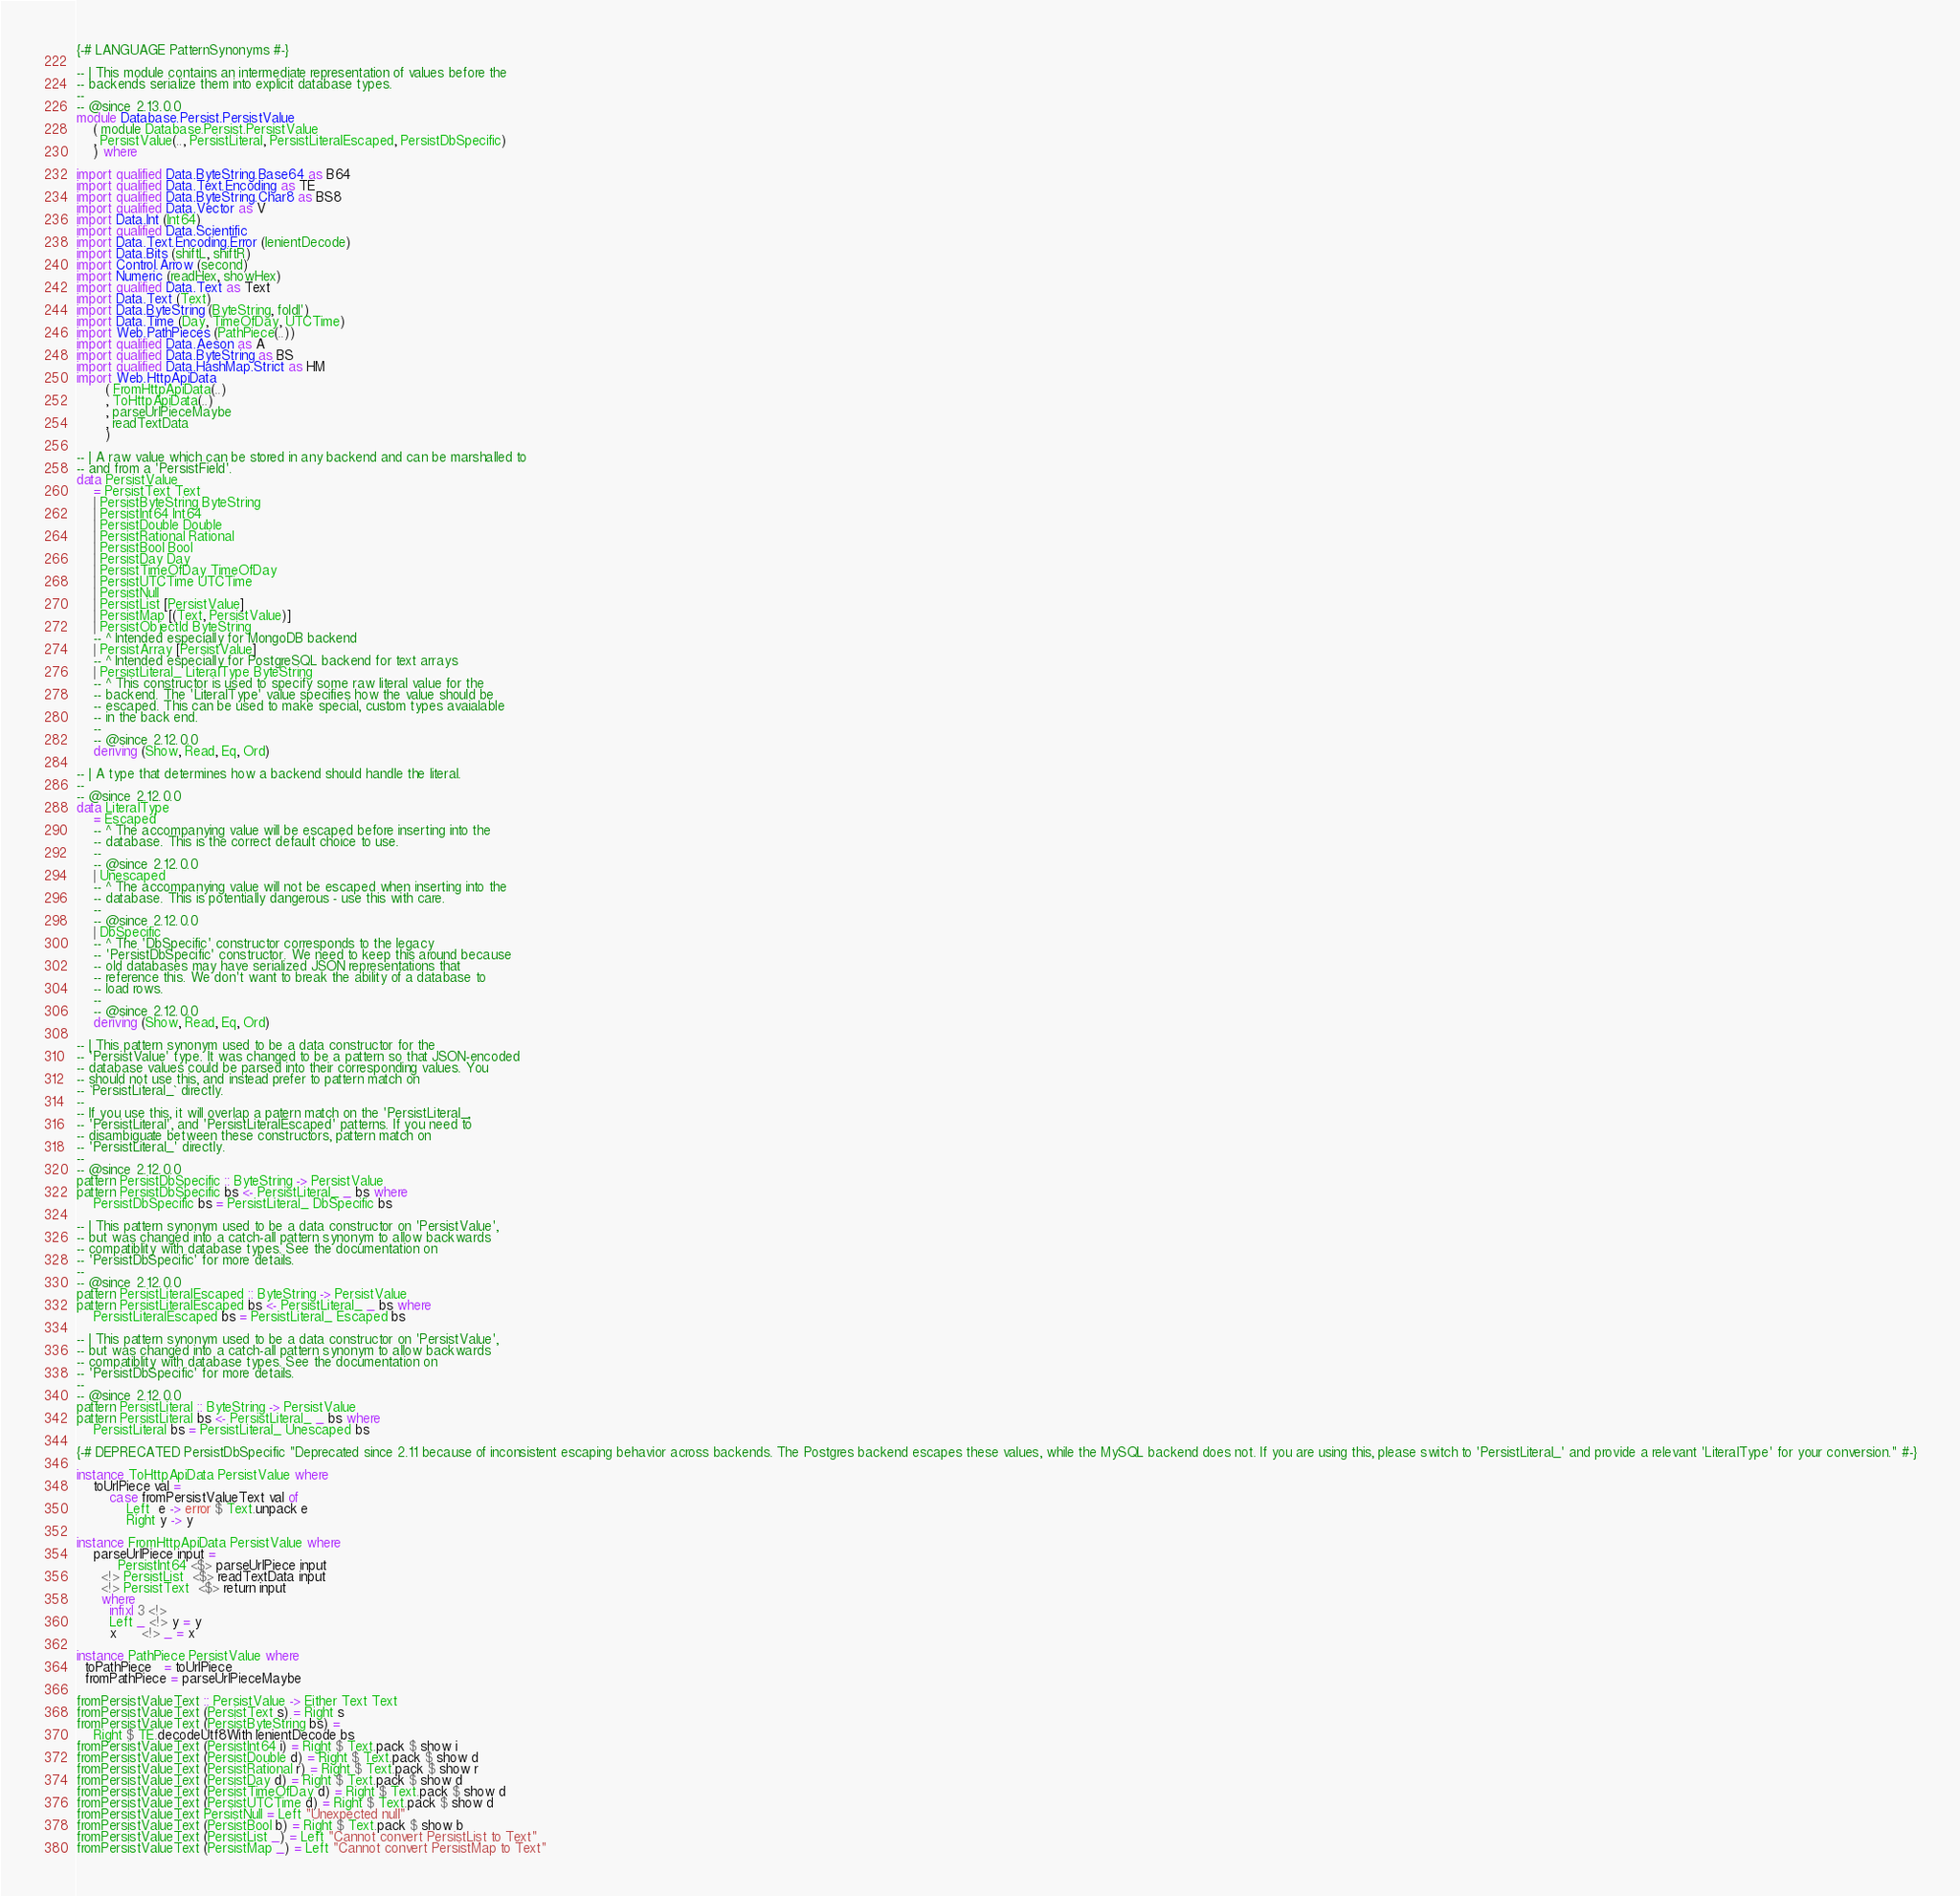<code> <loc_0><loc_0><loc_500><loc_500><_Haskell_>{-# LANGUAGE PatternSynonyms #-}

-- | This module contains an intermediate representation of values before the
-- backends serialize them into explicit database types.
--
-- @since 2.13.0.0
module Database.Persist.PersistValue
    ( module Database.Persist.PersistValue
    , PersistValue(.., PersistLiteral, PersistLiteralEscaped, PersistDbSpecific)
    ) where

import qualified Data.ByteString.Base64 as B64
import qualified Data.Text.Encoding as TE
import qualified Data.ByteString.Char8 as BS8
import qualified Data.Vector as V
import Data.Int (Int64)
import qualified Data.Scientific
import Data.Text.Encoding.Error (lenientDecode)
import Data.Bits (shiftL, shiftR)
import Control.Arrow (second)
import Numeric (readHex, showHex)
import qualified Data.Text as Text
import Data.Text (Text)
import Data.ByteString (ByteString, foldl')
import Data.Time (Day, TimeOfDay, UTCTime)
import Web.PathPieces (PathPiece(..))
import qualified Data.Aeson as A
import qualified Data.ByteString as BS
import qualified Data.HashMap.Strict as HM
import Web.HttpApiData
       ( FromHttpApiData(..)
       , ToHttpApiData(..)
       , parseUrlPieceMaybe
       , readTextData
       )

-- | A raw value which can be stored in any backend and can be marshalled to
-- and from a 'PersistField'.
data PersistValue
    = PersistText Text
    | PersistByteString ByteString
    | PersistInt64 Int64
    | PersistDouble Double
    | PersistRational Rational
    | PersistBool Bool
    | PersistDay Day
    | PersistTimeOfDay TimeOfDay
    | PersistUTCTime UTCTime
    | PersistNull
    | PersistList [PersistValue]
    | PersistMap [(Text, PersistValue)]
    | PersistObjectId ByteString
    -- ^ Intended especially for MongoDB backend
    | PersistArray [PersistValue]
    -- ^ Intended especially for PostgreSQL backend for text arrays
    | PersistLiteral_ LiteralType ByteString
    -- ^ This constructor is used to specify some raw literal value for the
    -- backend. The 'LiteralType' value specifies how the value should be
    -- escaped. This can be used to make special, custom types avaialable
    -- in the back end.
    --
    -- @since 2.12.0.0
    deriving (Show, Read, Eq, Ord)

-- | A type that determines how a backend should handle the literal.
--
-- @since 2.12.0.0
data LiteralType
    = Escaped
    -- ^ The accompanying value will be escaped before inserting into the
    -- database. This is the correct default choice to use.
    --
    -- @since 2.12.0.0
    | Unescaped
    -- ^ The accompanying value will not be escaped when inserting into the
    -- database. This is potentially dangerous - use this with care.
    --
    -- @since 2.12.0.0
    | DbSpecific
    -- ^ The 'DbSpecific' constructor corresponds to the legacy
    -- 'PersistDbSpecific' constructor. We need to keep this around because
    -- old databases may have serialized JSON representations that
    -- reference this. We don't want to break the ability of a database to
    -- load rows.
    --
    -- @since 2.12.0.0
    deriving (Show, Read, Eq, Ord)

-- | This pattern synonym used to be a data constructor for the
-- 'PersistValue' type. It was changed to be a pattern so that JSON-encoded
-- database values could be parsed into their corresponding values. You
-- should not use this, and instead prefer to pattern match on
-- `PersistLiteral_` directly.
--
-- If you use this, it will overlap a patern match on the 'PersistLiteral_,
-- 'PersistLiteral', and 'PersistLiteralEscaped' patterns. If you need to
-- disambiguate between these constructors, pattern match on
-- 'PersistLiteral_' directly.
--
-- @since 2.12.0.0
pattern PersistDbSpecific :: ByteString -> PersistValue
pattern PersistDbSpecific bs <- PersistLiteral_ _ bs where
    PersistDbSpecific bs = PersistLiteral_ DbSpecific bs

-- | This pattern synonym used to be a data constructor on 'PersistValue',
-- but was changed into a catch-all pattern synonym to allow backwards
-- compatiblity with database types. See the documentation on
-- 'PersistDbSpecific' for more details.
--
-- @since 2.12.0.0
pattern PersistLiteralEscaped :: ByteString -> PersistValue
pattern PersistLiteralEscaped bs <- PersistLiteral_ _ bs where
    PersistLiteralEscaped bs = PersistLiteral_ Escaped bs

-- | This pattern synonym used to be a data constructor on 'PersistValue',
-- but was changed into a catch-all pattern synonym to allow backwards
-- compatiblity with database types. See the documentation on
-- 'PersistDbSpecific' for more details.
--
-- @since 2.12.0.0
pattern PersistLiteral :: ByteString -> PersistValue
pattern PersistLiteral bs <- PersistLiteral_ _ bs where
    PersistLiteral bs = PersistLiteral_ Unescaped bs

{-# DEPRECATED PersistDbSpecific "Deprecated since 2.11 because of inconsistent escaping behavior across backends. The Postgres backend escapes these values, while the MySQL backend does not. If you are using this, please switch to 'PersistLiteral_' and provide a relevant 'LiteralType' for your conversion." #-}

instance ToHttpApiData PersistValue where
    toUrlPiece val =
        case fromPersistValueText val of
            Left  e -> error $ Text.unpack e
            Right y -> y

instance FromHttpApiData PersistValue where
    parseUrlPiece input =
          PersistInt64 <$> parseUrlPiece input
      <!> PersistList  <$> readTextData input
      <!> PersistText  <$> return input
      where
        infixl 3 <!>
        Left _ <!> y = y
        x      <!> _ = x

instance PathPiece PersistValue where
  toPathPiece   = toUrlPiece
  fromPathPiece = parseUrlPieceMaybe

fromPersistValueText :: PersistValue -> Either Text Text
fromPersistValueText (PersistText s) = Right s
fromPersistValueText (PersistByteString bs) =
    Right $ TE.decodeUtf8With lenientDecode bs
fromPersistValueText (PersistInt64 i) = Right $ Text.pack $ show i
fromPersistValueText (PersistDouble d) = Right $ Text.pack $ show d
fromPersistValueText (PersistRational r) = Right $ Text.pack $ show r
fromPersistValueText (PersistDay d) = Right $ Text.pack $ show d
fromPersistValueText (PersistTimeOfDay d) = Right $ Text.pack $ show d
fromPersistValueText (PersistUTCTime d) = Right $ Text.pack $ show d
fromPersistValueText PersistNull = Left "Unexpected null"
fromPersistValueText (PersistBool b) = Right $ Text.pack $ show b
fromPersistValueText (PersistList _) = Left "Cannot convert PersistList to Text"
fromPersistValueText (PersistMap _) = Left "Cannot convert PersistMap to Text"</code> 